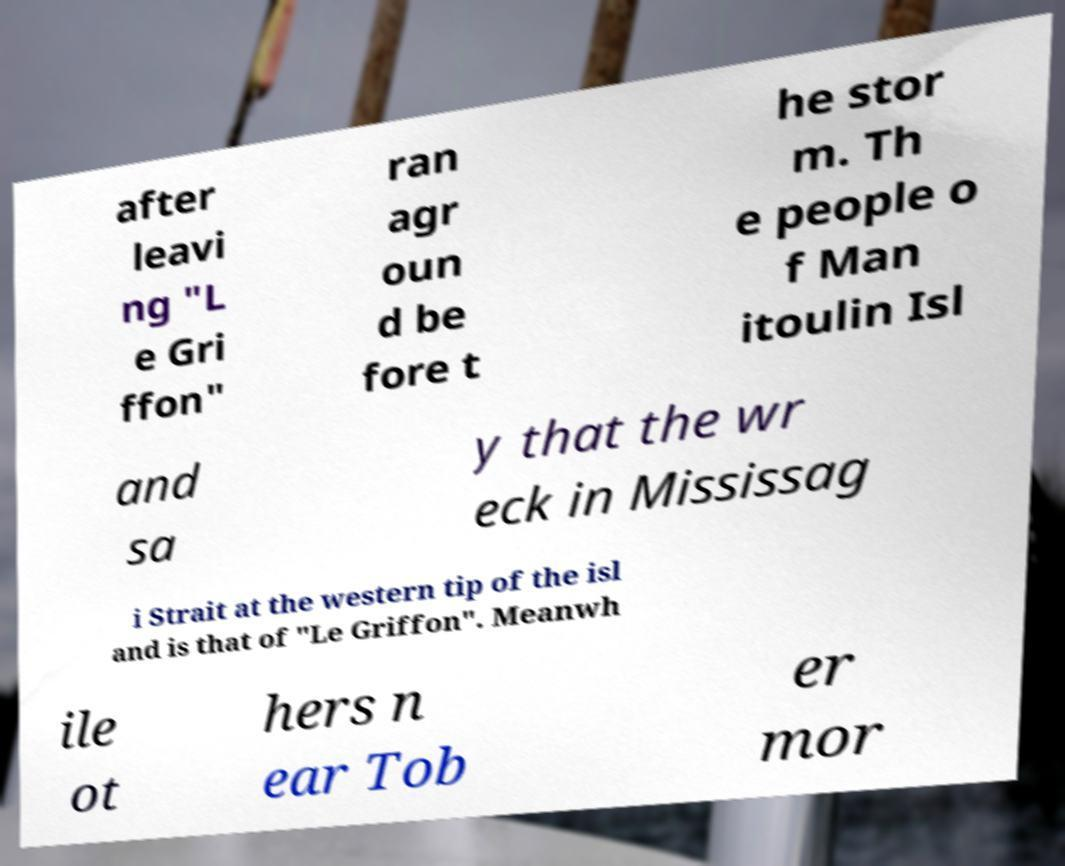Can you read and provide the text displayed in the image?This photo seems to have some interesting text. Can you extract and type it out for me? after leavi ng "L e Gri ffon" ran agr oun d be fore t he stor m. Th e people o f Man itoulin Isl and sa y that the wr eck in Mississag i Strait at the western tip of the isl and is that of "Le Griffon". Meanwh ile ot hers n ear Tob er mor 